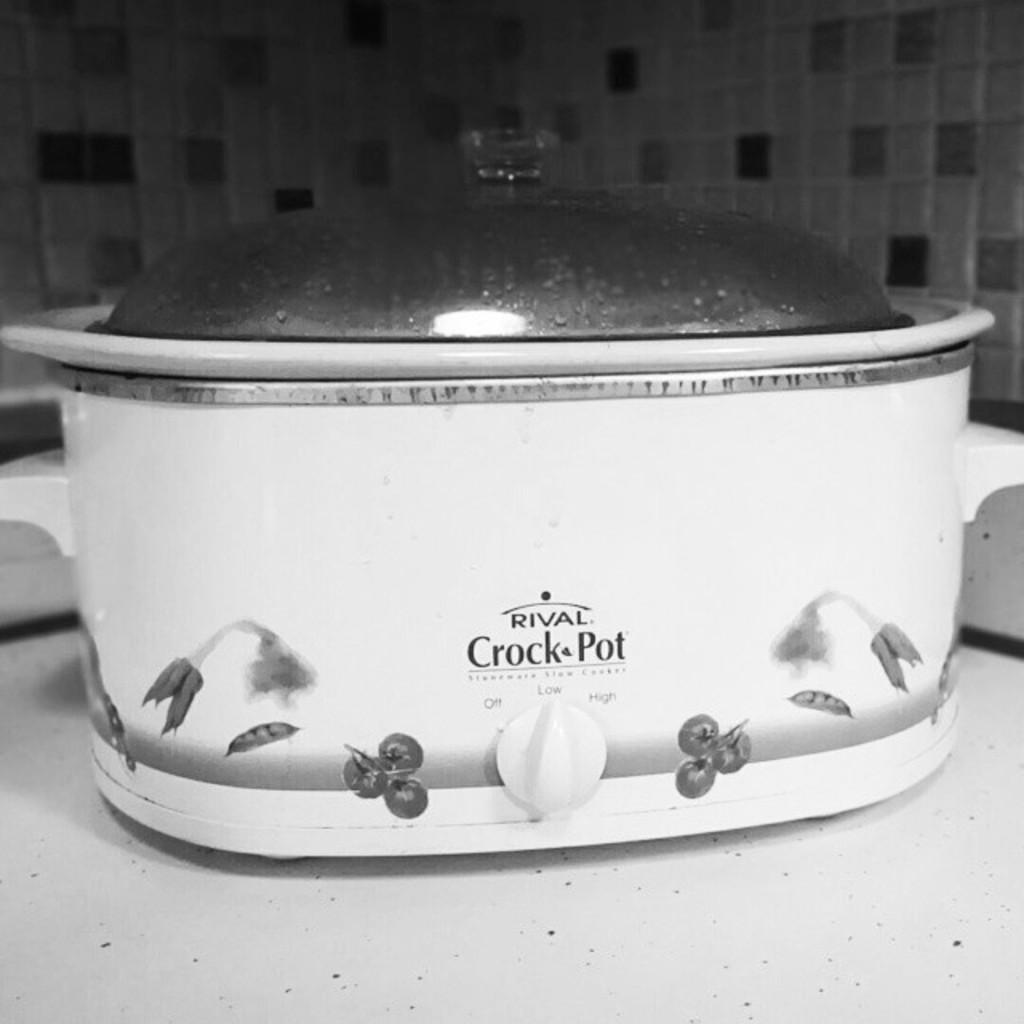How would you summarize this image in a sentence or two? It is a black and white picture. In the center of the image there is a white platform. On the platform, we can see one container with a lid. And we can see some text on the container. In the background, we can see a few other objects. 